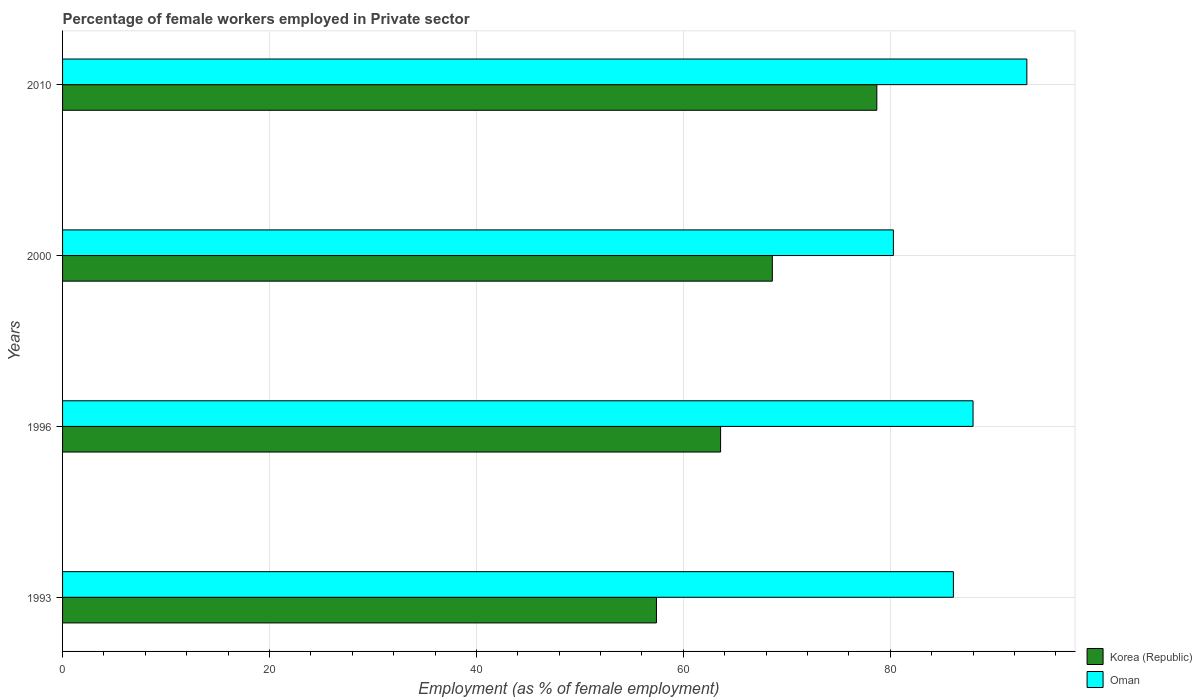Are the number of bars per tick equal to the number of legend labels?
Ensure brevity in your answer.  Yes. Are the number of bars on each tick of the Y-axis equal?
Offer a very short reply. Yes. How many bars are there on the 4th tick from the top?
Give a very brief answer. 2. How many bars are there on the 3rd tick from the bottom?
Give a very brief answer. 2. What is the label of the 4th group of bars from the top?
Ensure brevity in your answer.  1993. What is the percentage of females employed in Private sector in Oman in 2010?
Your response must be concise. 93.2. Across all years, what is the maximum percentage of females employed in Private sector in Korea (Republic)?
Your answer should be very brief. 78.7. Across all years, what is the minimum percentage of females employed in Private sector in Oman?
Ensure brevity in your answer.  80.3. In which year was the percentage of females employed in Private sector in Oman minimum?
Provide a succinct answer. 2000. What is the total percentage of females employed in Private sector in Korea (Republic) in the graph?
Offer a terse response. 268.3. What is the difference between the percentage of females employed in Private sector in Oman in 1996 and that in 2000?
Provide a succinct answer. 7.7. What is the difference between the percentage of females employed in Private sector in Korea (Republic) in 1996 and the percentage of females employed in Private sector in Oman in 2000?
Offer a very short reply. -16.7. What is the average percentage of females employed in Private sector in Oman per year?
Keep it short and to the point. 86.9. In the year 1993, what is the difference between the percentage of females employed in Private sector in Oman and percentage of females employed in Private sector in Korea (Republic)?
Ensure brevity in your answer.  28.7. In how many years, is the percentage of females employed in Private sector in Oman greater than 24 %?
Provide a short and direct response. 4. What is the ratio of the percentage of females employed in Private sector in Korea (Republic) in 1993 to that in 1996?
Offer a very short reply. 0.9. Is the difference between the percentage of females employed in Private sector in Oman in 2000 and 2010 greater than the difference between the percentage of females employed in Private sector in Korea (Republic) in 2000 and 2010?
Keep it short and to the point. No. What is the difference between the highest and the second highest percentage of females employed in Private sector in Oman?
Ensure brevity in your answer.  5.2. What is the difference between the highest and the lowest percentage of females employed in Private sector in Oman?
Your answer should be compact. 12.9. In how many years, is the percentage of females employed in Private sector in Oman greater than the average percentage of females employed in Private sector in Oman taken over all years?
Ensure brevity in your answer.  2. Is the sum of the percentage of females employed in Private sector in Oman in 1996 and 2000 greater than the maximum percentage of females employed in Private sector in Korea (Republic) across all years?
Offer a terse response. Yes. What does the 1st bar from the top in 2000 represents?
Your answer should be compact. Oman. What does the 2nd bar from the bottom in 2010 represents?
Keep it short and to the point. Oman. How many bars are there?
Give a very brief answer. 8. How many years are there in the graph?
Make the answer very short. 4. Does the graph contain grids?
Give a very brief answer. Yes. How many legend labels are there?
Provide a short and direct response. 2. How are the legend labels stacked?
Offer a terse response. Vertical. What is the title of the graph?
Make the answer very short. Percentage of female workers employed in Private sector. Does "Mozambique" appear as one of the legend labels in the graph?
Your response must be concise. No. What is the label or title of the X-axis?
Offer a very short reply. Employment (as % of female employment). What is the Employment (as % of female employment) in Korea (Republic) in 1993?
Your answer should be very brief. 57.4. What is the Employment (as % of female employment) of Oman in 1993?
Your response must be concise. 86.1. What is the Employment (as % of female employment) in Korea (Republic) in 1996?
Provide a short and direct response. 63.6. What is the Employment (as % of female employment) in Korea (Republic) in 2000?
Keep it short and to the point. 68.6. What is the Employment (as % of female employment) of Oman in 2000?
Provide a succinct answer. 80.3. What is the Employment (as % of female employment) in Korea (Republic) in 2010?
Offer a very short reply. 78.7. What is the Employment (as % of female employment) of Oman in 2010?
Provide a succinct answer. 93.2. Across all years, what is the maximum Employment (as % of female employment) of Korea (Republic)?
Offer a terse response. 78.7. Across all years, what is the maximum Employment (as % of female employment) of Oman?
Make the answer very short. 93.2. Across all years, what is the minimum Employment (as % of female employment) of Korea (Republic)?
Ensure brevity in your answer.  57.4. Across all years, what is the minimum Employment (as % of female employment) in Oman?
Your answer should be very brief. 80.3. What is the total Employment (as % of female employment) in Korea (Republic) in the graph?
Ensure brevity in your answer.  268.3. What is the total Employment (as % of female employment) in Oman in the graph?
Your response must be concise. 347.6. What is the difference between the Employment (as % of female employment) of Oman in 1993 and that in 1996?
Keep it short and to the point. -1.9. What is the difference between the Employment (as % of female employment) in Korea (Republic) in 1993 and that in 2000?
Offer a very short reply. -11.2. What is the difference between the Employment (as % of female employment) of Korea (Republic) in 1993 and that in 2010?
Keep it short and to the point. -21.3. What is the difference between the Employment (as % of female employment) of Oman in 1993 and that in 2010?
Provide a short and direct response. -7.1. What is the difference between the Employment (as % of female employment) of Oman in 1996 and that in 2000?
Keep it short and to the point. 7.7. What is the difference between the Employment (as % of female employment) in Korea (Republic) in 1996 and that in 2010?
Offer a very short reply. -15.1. What is the difference between the Employment (as % of female employment) of Korea (Republic) in 2000 and that in 2010?
Keep it short and to the point. -10.1. What is the difference between the Employment (as % of female employment) in Oman in 2000 and that in 2010?
Ensure brevity in your answer.  -12.9. What is the difference between the Employment (as % of female employment) in Korea (Republic) in 1993 and the Employment (as % of female employment) in Oman in 1996?
Make the answer very short. -30.6. What is the difference between the Employment (as % of female employment) of Korea (Republic) in 1993 and the Employment (as % of female employment) of Oman in 2000?
Offer a terse response. -22.9. What is the difference between the Employment (as % of female employment) of Korea (Republic) in 1993 and the Employment (as % of female employment) of Oman in 2010?
Provide a succinct answer. -35.8. What is the difference between the Employment (as % of female employment) of Korea (Republic) in 1996 and the Employment (as % of female employment) of Oman in 2000?
Your answer should be very brief. -16.7. What is the difference between the Employment (as % of female employment) of Korea (Republic) in 1996 and the Employment (as % of female employment) of Oman in 2010?
Provide a succinct answer. -29.6. What is the difference between the Employment (as % of female employment) of Korea (Republic) in 2000 and the Employment (as % of female employment) of Oman in 2010?
Your response must be concise. -24.6. What is the average Employment (as % of female employment) in Korea (Republic) per year?
Your answer should be compact. 67.08. What is the average Employment (as % of female employment) of Oman per year?
Your response must be concise. 86.9. In the year 1993, what is the difference between the Employment (as % of female employment) in Korea (Republic) and Employment (as % of female employment) in Oman?
Your response must be concise. -28.7. In the year 1996, what is the difference between the Employment (as % of female employment) in Korea (Republic) and Employment (as % of female employment) in Oman?
Ensure brevity in your answer.  -24.4. In the year 2010, what is the difference between the Employment (as % of female employment) in Korea (Republic) and Employment (as % of female employment) in Oman?
Provide a short and direct response. -14.5. What is the ratio of the Employment (as % of female employment) of Korea (Republic) in 1993 to that in 1996?
Give a very brief answer. 0.9. What is the ratio of the Employment (as % of female employment) of Oman in 1993 to that in 1996?
Make the answer very short. 0.98. What is the ratio of the Employment (as % of female employment) in Korea (Republic) in 1993 to that in 2000?
Provide a short and direct response. 0.84. What is the ratio of the Employment (as % of female employment) of Oman in 1993 to that in 2000?
Ensure brevity in your answer.  1.07. What is the ratio of the Employment (as % of female employment) of Korea (Republic) in 1993 to that in 2010?
Provide a short and direct response. 0.73. What is the ratio of the Employment (as % of female employment) in Oman in 1993 to that in 2010?
Provide a short and direct response. 0.92. What is the ratio of the Employment (as % of female employment) in Korea (Republic) in 1996 to that in 2000?
Ensure brevity in your answer.  0.93. What is the ratio of the Employment (as % of female employment) of Oman in 1996 to that in 2000?
Your response must be concise. 1.1. What is the ratio of the Employment (as % of female employment) of Korea (Republic) in 1996 to that in 2010?
Ensure brevity in your answer.  0.81. What is the ratio of the Employment (as % of female employment) in Oman in 1996 to that in 2010?
Provide a succinct answer. 0.94. What is the ratio of the Employment (as % of female employment) in Korea (Republic) in 2000 to that in 2010?
Offer a terse response. 0.87. What is the ratio of the Employment (as % of female employment) of Oman in 2000 to that in 2010?
Your answer should be compact. 0.86. What is the difference between the highest and the second highest Employment (as % of female employment) in Oman?
Your answer should be very brief. 5.2. What is the difference between the highest and the lowest Employment (as % of female employment) in Korea (Republic)?
Give a very brief answer. 21.3. 